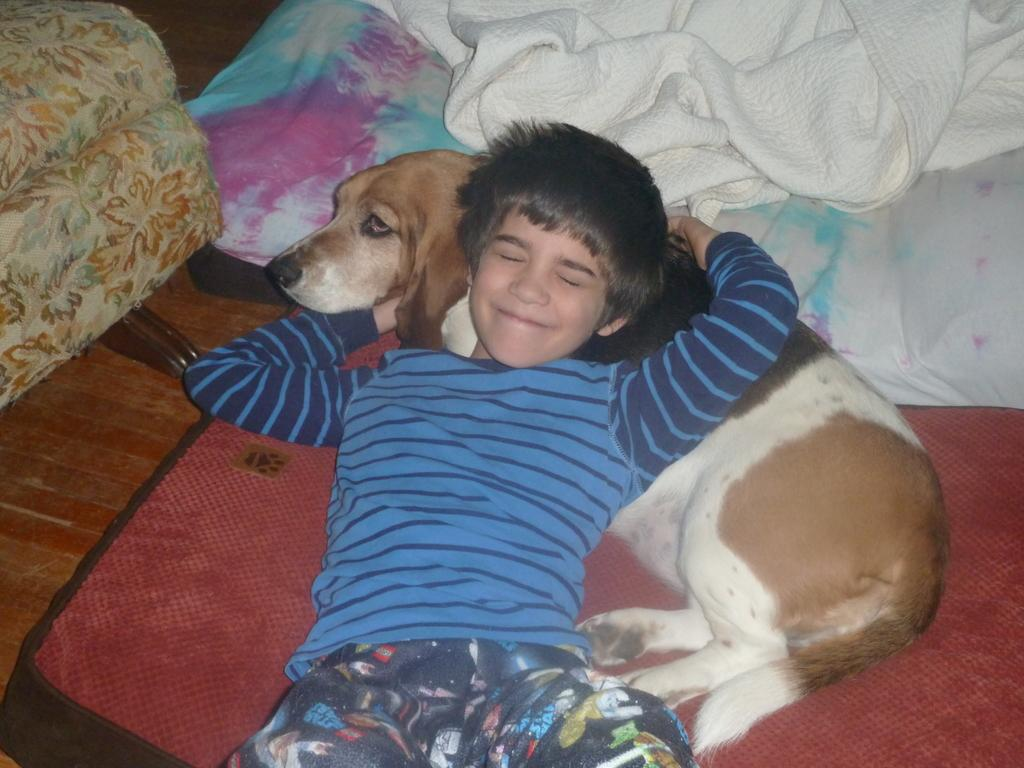Who or what can be seen in the image? There is a boy and a dog in the image. What is the setting of the image? The boy and dog are laid on a carpet. Are there any additional items or objects in the image? Yes, there are blankets in the image. Can you see any hills or shades in the image? There are no hills or shades visible in the image. Is there a cobweb present in the image? There is no cobweb present in the image. 